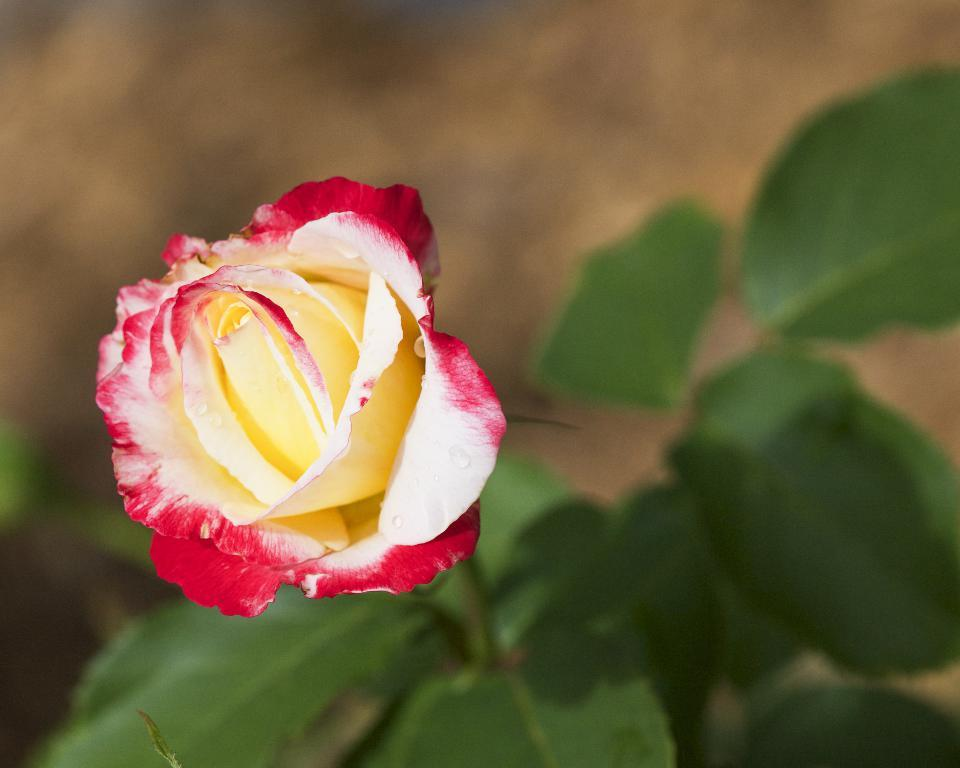What type of flower is on the left side of the image? There is a rose flower on the left side of the image. What else can be seen at the bottom of the image? Leaves are present at the bottom of the image. Where is the cow located in the image? There is no cow present in the image. What type of office equipment can be seen in the image? There is no office equipment present in the image. 